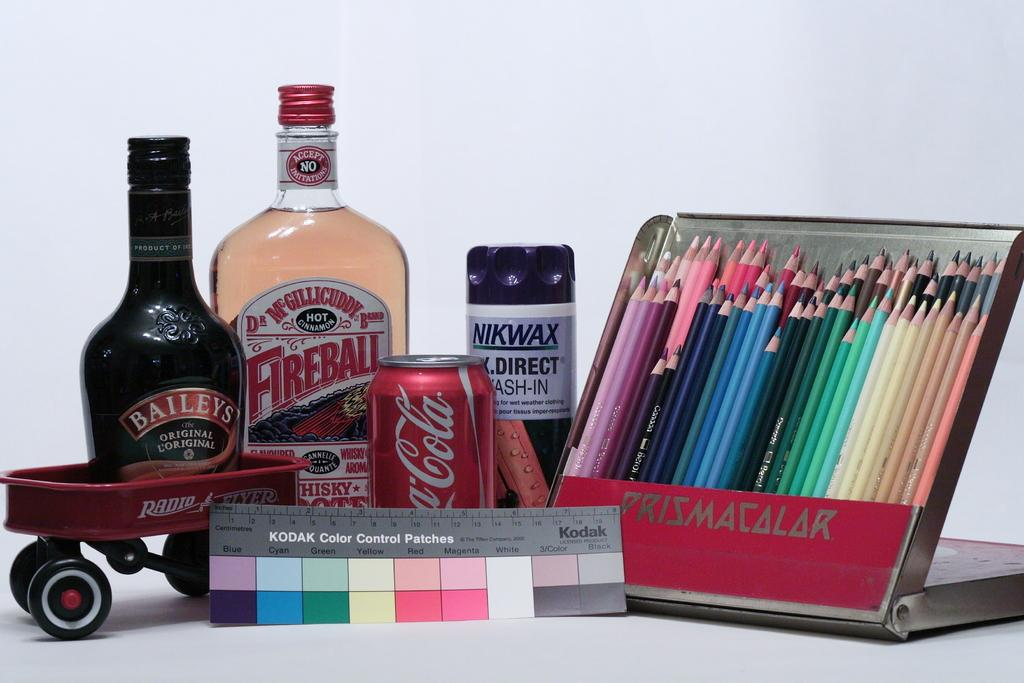<image>
Share a concise interpretation of the image provided. A Kodak Color Control Patch sits in front of an assortment of brand name items. 